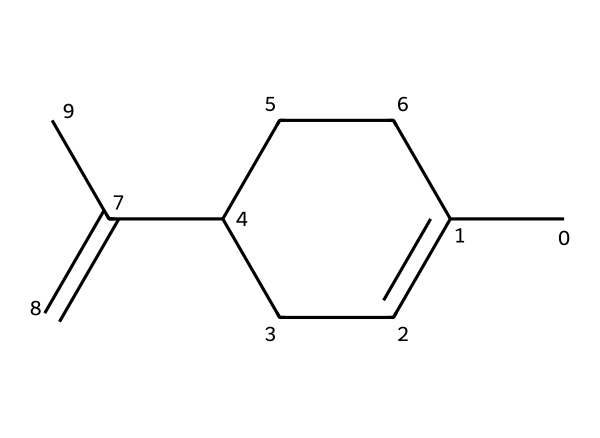What is the molecular formula of limonene? To find the molecular formula, we can identify the elements present in the SMILES representation. Counting the carbon and hydrogen atoms yields 10 carbons and 16 hydrogens. Therefore, the molecular formula is C10H16.
Answer: C10H16 How many rings are present in the limonene structure? By analyzing the SMILES representation, we notice the 'C1=CCC(...)C' notation, indicating that there is one cyclic structure (ring) in the molecule.
Answer: one What type of carbon-carbon bonds are present in limonene? The presence of the '=' symbol in the SMILES indicates that there is at least one double bond in the molecule. The structure has both single and double bonds among its carbon atoms, correlating with the typical bonding in terpenes.
Answer: single and double Which part of the structure indicates limonene is a terpene? The fact that limonene consists primarily of carbon and hydrogen atoms, along with its cyclic structure, corresponds to the defining characteristics of terpenes, which typically have a structure derived from isoprene units.
Answer: cyclic structure What is the degree of unsaturation in limonene? To calculate the degree of unsaturation, we use the formula: degree of unsaturation = (2C + 2 + N - H - X)/2. For limonene (C10H16), this calculates to 1, indicating one ring or double bond is present.
Answer: 1 